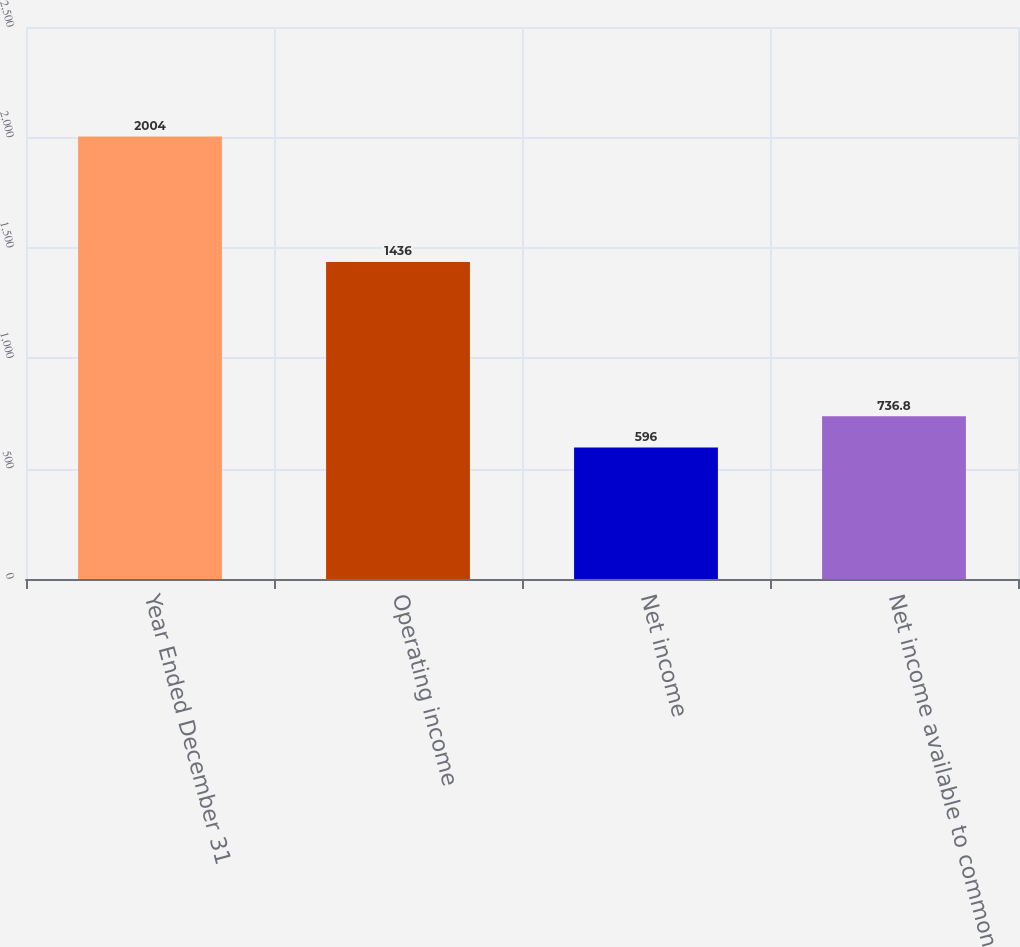Convert chart to OTSL. <chart><loc_0><loc_0><loc_500><loc_500><bar_chart><fcel>Year Ended December 31<fcel>Operating income<fcel>Net income<fcel>Net income available to common<nl><fcel>2004<fcel>1436<fcel>596<fcel>736.8<nl></chart> 